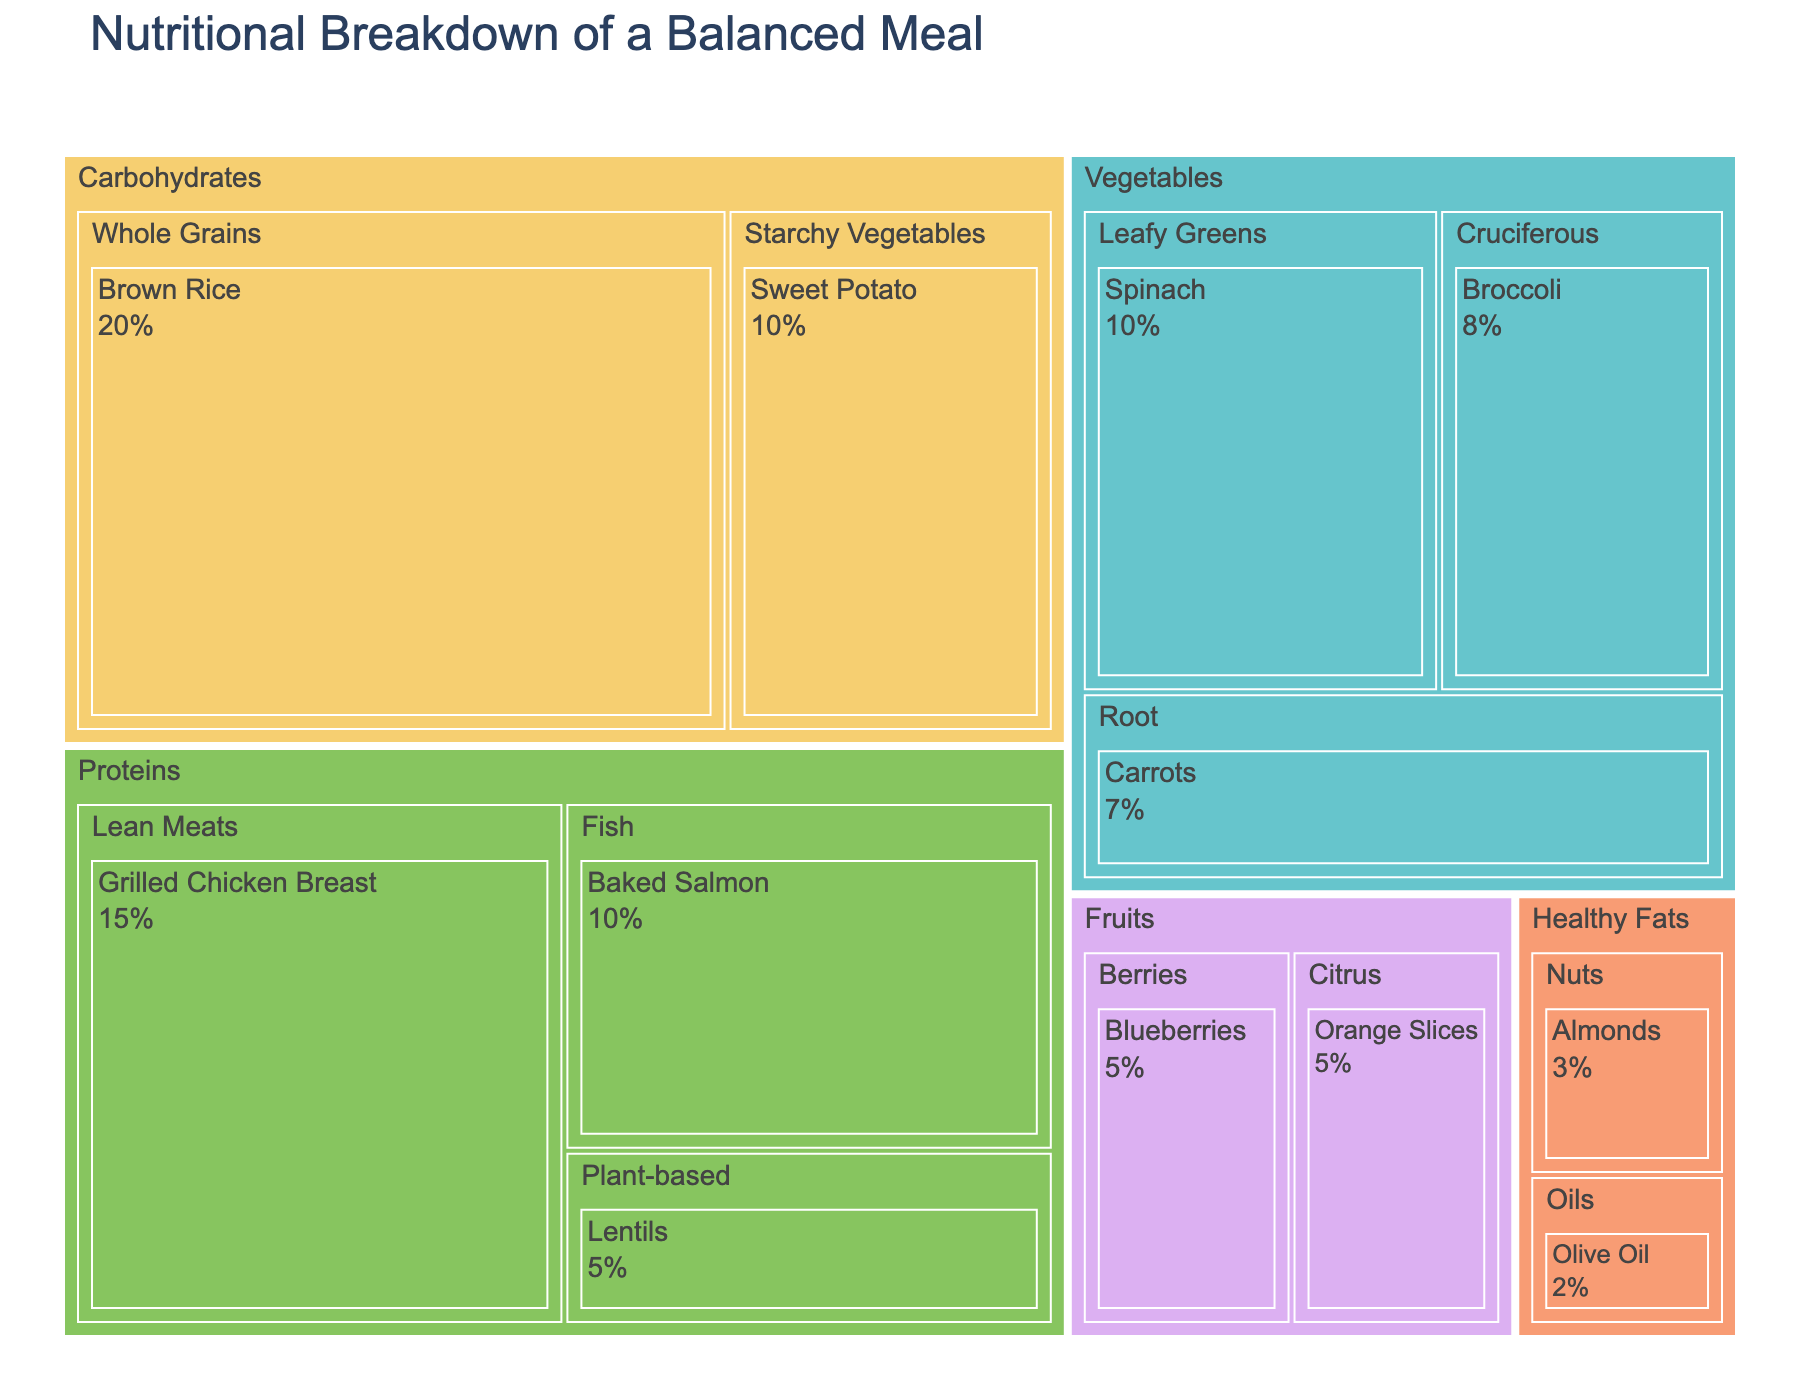What is the title of the treemap? The title of the treemap is usually located at the top of the figure and provides a summary of the data presented. In this case, the title shown is "Nutritional Breakdown of a Balanced Meal".
Answer: Nutritional Breakdown of a Balanced Meal Which food group has the highest percentage in the meal? The food group with the largest proportion will have the biggest area in the treemap. Here, "Carbohydrates" covers the largest area in the chart.
Answer: Carbohydrates What is the total percentage contributed by all protein sources combined? To find the total percentage, add the percentages of all items under the "Proteins" food group: Grilled Chicken Breast (15) + Baked Salmon (10) + Lentils (5). This gives a total of 15 + 10 + 5 = 30%.
Answer: 30% Which individual item contributes the least percentage to the meal? The smallest individual area in the treemap represents the item with the least percentage. "Olive Oil" in the "Healthy Fats" category has the smallest area with 2%.
Answer: Olive Oil How does the percentage of Brown Rice compare to the combined percentage of all fruits? The percentage of Brown Rice is 20%. To find the combined percentage of all fruits, sum the percentages of Blueberries (5) and Orange Slices (5), which is 5 + 5 = 10%. Brown Rice (20%) is greater than the combined percentage of all fruits (10%).
Answer: Brown Rice is greater What is the total percentage contribution of all food items in the vegetables category? Sum the percentages of Spinach (10), Broccoli (8), and Carrots (7). This gives 10 + 8 + 7 = 25%.
Answer: 25% Among the protein items, which has the highest percentage? Compare the percentages of the protein items: Grilled Chicken Breast (15), Baked Salmon (10), and Lentils (5). Grilled Chicken Breast has the highest percentage with 15%.
Answer: Grilled Chicken Breast What is the ratio of the percentage of Whole Grains to the percentage of Starchy Vegetables? The percentage of Whole Grains (Brown Rice) is 20%, and the percentage of Starchy Vegetables (Sweet Potato) is 10%. Therefore, the ratio is 20% to 10%, which simplifies to 2:1.
Answer: 2:1 Which food group has the lowest combined percentage, and what is that percentage? Compare the combined percentages of all food groups. Healthy Fats has the lowest combined percentage with Almonds (3) + Olive Oil (2) = 5%.
Answer: Healthy Fats with 5% What percentage is contributed by fruit items alone? Add the percentages of Blueberries (5) and Orange Slices (5) to get the total contribution from fruits. This gives 5 + 5 = 10%.
Answer: 10% 